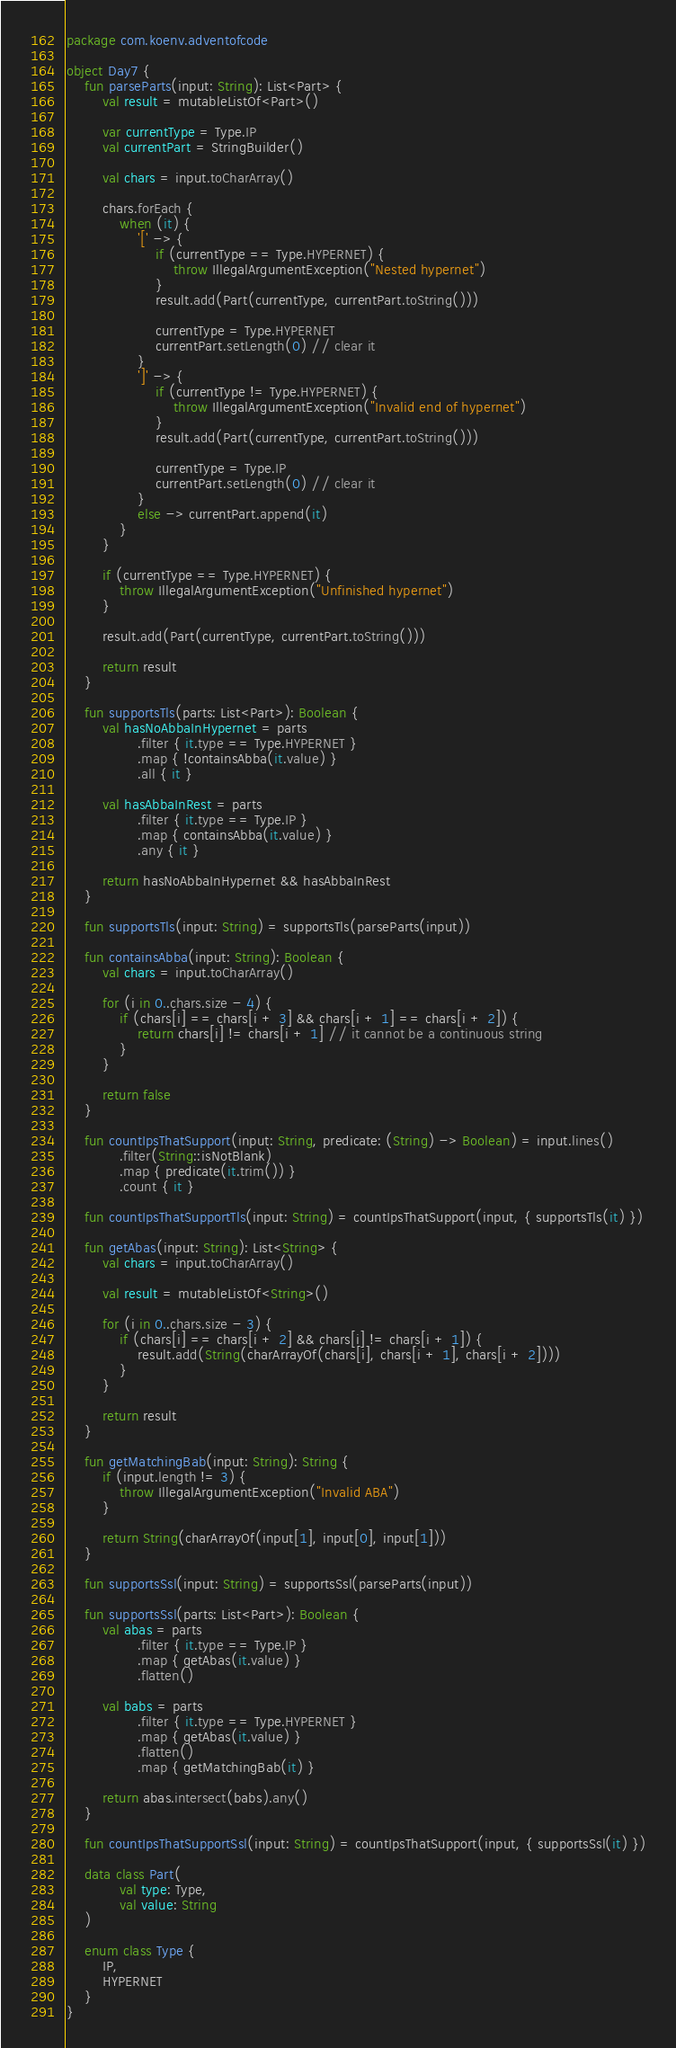Convert code to text. <code><loc_0><loc_0><loc_500><loc_500><_Kotlin_>package com.koenv.adventofcode

object Day7 {
    fun parseParts(input: String): List<Part> {
        val result = mutableListOf<Part>()

        var currentType = Type.IP
        val currentPart = StringBuilder()

        val chars = input.toCharArray()

        chars.forEach {
            when (it) {
                '[' -> {
                    if (currentType == Type.HYPERNET) {
                        throw IllegalArgumentException("Nested hypernet")
                    }
                    result.add(Part(currentType, currentPart.toString()))

                    currentType = Type.HYPERNET
                    currentPart.setLength(0) // clear it
                }
                ']' -> {
                    if (currentType != Type.HYPERNET) {
                        throw IllegalArgumentException("Invalid end of hypernet")
                    }
                    result.add(Part(currentType, currentPart.toString()))

                    currentType = Type.IP
                    currentPart.setLength(0) // clear it
                }
                else -> currentPart.append(it)
            }
        }

        if (currentType == Type.HYPERNET) {
            throw IllegalArgumentException("Unfinished hypernet")
        }

        result.add(Part(currentType, currentPart.toString()))

        return result
    }

    fun supportsTls(parts: List<Part>): Boolean {
        val hasNoAbbaInHypernet = parts
                .filter { it.type == Type.HYPERNET }
                .map { !containsAbba(it.value) }
                .all { it }

        val hasAbbaInRest = parts
                .filter { it.type == Type.IP }
                .map { containsAbba(it.value) }
                .any { it }

        return hasNoAbbaInHypernet && hasAbbaInRest
    }

    fun supportsTls(input: String) = supportsTls(parseParts(input))

    fun containsAbba(input: String): Boolean {
        val chars = input.toCharArray()

        for (i in 0..chars.size - 4) {
            if (chars[i] == chars[i + 3] && chars[i + 1] == chars[i + 2]) {
                return chars[i] != chars[i + 1] // it cannot be a continuous string
            }
        }

        return false
    }

    fun countIpsThatSupport(input: String, predicate: (String) -> Boolean) = input.lines()
            .filter(String::isNotBlank)
            .map { predicate(it.trim()) }
            .count { it }

    fun countIpsThatSupportTls(input: String) = countIpsThatSupport(input, { supportsTls(it) })

    fun getAbas(input: String): List<String> {
        val chars = input.toCharArray()

        val result = mutableListOf<String>()

        for (i in 0..chars.size - 3) {
            if (chars[i] == chars[i + 2] && chars[i] != chars[i + 1]) {
                result.add(String(charArrayOf(chars[i], chars[i + 1], chars[i + 2])))
            }
        }

        return result
    }

    fun getMatchingBab(input: String): String {
        if (input.length != 3) {
            throw IllegalArgumentException("Invalid ABA")
        }

        return String(charArrayOf(input[1], input[0], input[1]))
    }

    fun supportsSsl(input: String) = supportsSsl(parseParts(input))

    fun supportsSsl(parts: List<Part>): Boolean {
        val abas = parts
                .filter { it.type == Type.IP }
                .map { getAbas(it.value) }
                .flatten()

        val babs = parts
                .filter { it.type == Type.HYPERNET }
                .map { getAbas(it.value) }
                .flatten()
                .map { getMatchingBab(it) }

        return abas.intersect(babs).any()
    }

    fun countIpsThatSupportSsl(input: String) = countIpsThatSupport(input, { supportsSsl(it) })

    data class Part(
            val type: Type,
            val value: String
    )

    enum class Type {
        IP,
        HYPERNET
    }
}</code> 